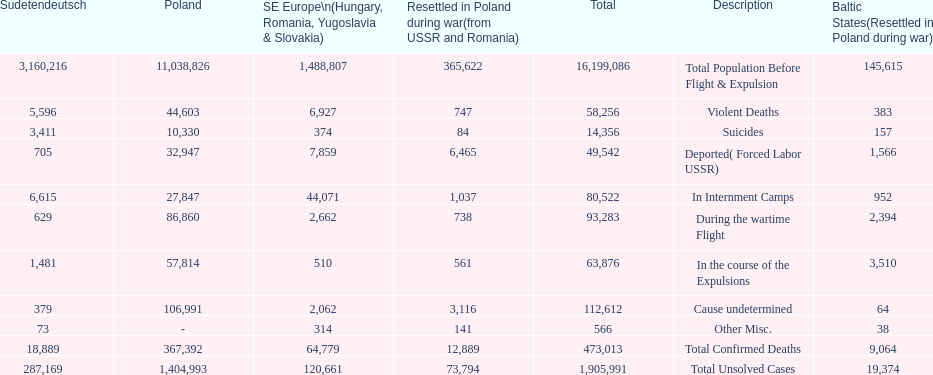What is the total of deaths in internment camps and during the wartime flight? 173,805. 